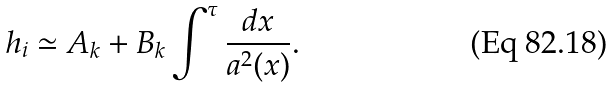<formula> <loc_0><loc_0><loc_500><loc_500>h _ { i } \simeq A _ { k } + B _ { k } \int ^ { \tau } \frac { d x } { a ^ { 2 } ( x ) } .</formula> 